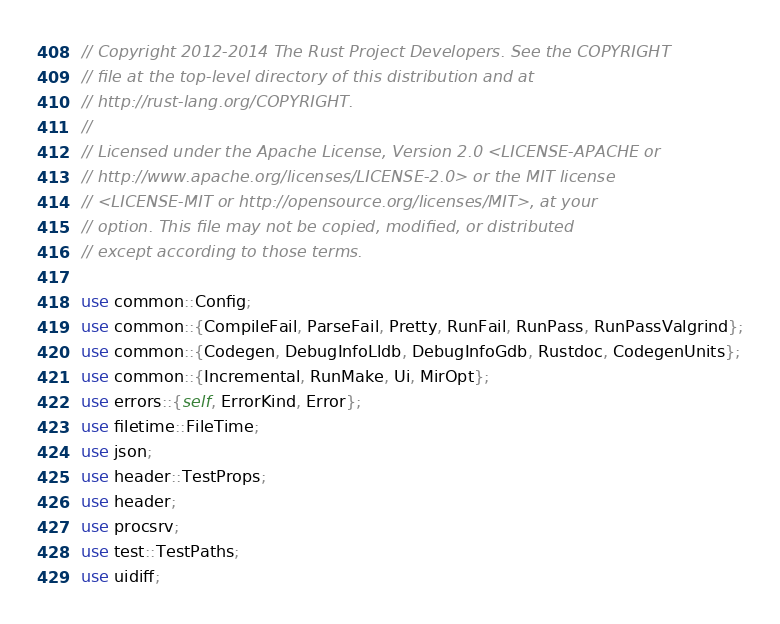<code> <loc_0><loc_0><loc_500><loc_500><_Rust_>// Copyright 2012-2014 The Rust Project Developers. See the COPYRIGHT
// file at the top-level directory of this distribution and at
// http://rust-lang.org/COPYRIGHT.
//
// Licensed under the Apache License, Version 2.0 <LICENSE-APACHE or
// http://www.apache.org/licenses/LICENSE-2.0> or the MIT license
// <LICENSE-MIT or http://opensource.org/licenses/MIT>, at your
// option. This file may not be copied, modified, or distributed
// except according to those terms.

use common::Config;
use common::{CompileFail, ParseFail, Pretty, RunFail, RunPass, RunPassValgrind};
use common::{Codegen, DebugInfoLldb, DebugInfoGdb, Rustdoc, CodegenUnits};
use common::{Incremental, RunMake, Ui, MirOpt};
use errors::{self, ErrorKind, Error};
use filetime::FileTime;
use json;
use header::TestProps;
use header;
use procsrv;
use test::TestPaths;
use uidiff;</code> 